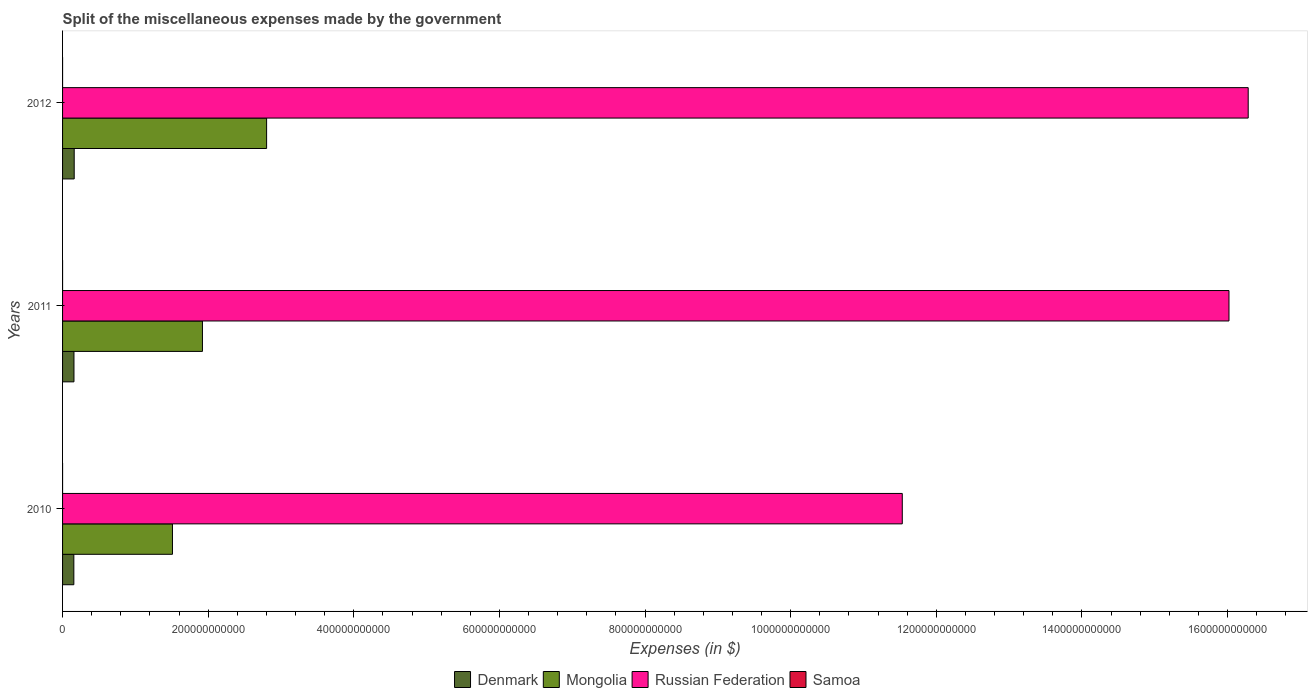How many different coloured bars are there?
Keep it short and to the point. 4. How many groups of bars are there?
Offer a very short reply. 3. Are the number of bars per tick equal to the number of legend labels?
Your response must be concise. Yes. How many bars are there on the 2nd tick from the top?
Provide a succinct answer. 4. What is the label of the 1st group of bars from the top?
Your response must be concise. 2012. In how many cases, is the number of bars for a given year not equal to the number of legend labels?
Offer a very short reply. 0. What is the miscellaneous expenses made by the government in Samoa in 2010?
Make the answer very short. 1.65e+04. Across all years, what is the maximum miscellaneous expenses made by the government in Samoa?
Provide a succinct answer. 1.76e+04. Across all years, what is the minimum miscellaneous expenses made by the government in Russian Federation?
Your answer should be very brief. 1.15e+12. In which year was the miscellaneous expenses made by the government in Denmark maximum?
Provide a succinct answer. 2012. What is the total miscellaneous expenses made by the government in Samoa in the graph?
Provide a short and direct response. 5.14e+04. What is the difference between the miscellaneous expenses made by the government in Russian Federation in 2010 and that in 2011?
Provide a succinct answer. -4.49e+11. What is the difference between the miscellaneous expenses made by the government in Mongolia in 2011 and the miscellaneous expenses made by the government in Samoa in 2012?
Ensure brevity in your answer.  1.92e+11. What is the average miscellaneous expenses made by the government in Denmark per year?
Offer a terse response. 1.57e+1. In the year 2012, what is the difference between the miscellaneous expenses made by the government in Samoa and miscellaneous expenses made by the government in Russian Federation?
Ensure brevity in your answer.  -1.63e+12. What is the ratio of the miscellaneous expenses made by the government in Russian Federation in 2010 to that in 2011?
Offer a very short reply. 0.72. Is the difference between the miscellaneous expenses made by the government in Samoa in 2011 and 2012 greater than the difference between the miscellaneous expenses made by the government in Russian Federation in 2011 and 2012?
Offer a very short reply. Yes. What is the difference between the highest and the second highest miscellaneous expenses made by the government in Samoa?
Give a very brief answer. 394.36. What is the difference between the highest and the lowest miscellaneous expenses made by the government in Mongolia?
Provide a short and direct response. 1.29e+11. Is the sum of the miscellaneous expenses made by the government in Samoa in 2011 and 2012 greater than the maximum miscellaneous expenses made by the government in Denmark across all years?
Your response must be concise. No. What does the 2nd bar from the top in 2011 represents?
Provide a short and direct response. Russian Federation. What does the 4th bar from the bottom in 2010 represents?
Provide a succinct answer. Samoa. Are all the bars in the graph horizontal?
Offer a very short reply. Yes. How many years are there in the graph?
Make the answer very short. 3. What is the difference between two consecutive major ticks on the X-axis?
Your answer should be compact. 2.00e+11. Are the values on the major ticks of X-axis written in scientific E-notation?
Your answer should be very brief. No. Does the graph contain grids?
Your response must be concise. No. Where does the legend appear in the graph?
Give a very brief answer. Bottom center. How many legend labels are there?
Ensure brevity in your answer.  4. How are the legend labels stacked?
Offer a very short reply. Horizontal. What is the title of the graph?
Give a very brief answer. Split of the miscellaneous expenses made by the government. What is the label or title of the X-axis?
Make the answer very short. Expenses (in $). What is the Expenses (in $) in Denmark in 2010?
Offer a terse response. 1.55e+1. What is the Expenses (in $) of Mongolia in 2010?
Give a very brief answer. 1.51e+11. What is the Expenses (in $) of Russian Federation in 2010?
Provide a succinct answer. 1.15e+12. What is the Expenses (in $) in Samoa in 2010?
Your answer should be compact. 1.65e+04. What is the Expenses (in $) in Denmark in 2011?
Give a very brief answer. 1.57e+1. What is the Expenses (in $) of Mongolia in 2011?
Ensure brevity in your answer.  1.92e+11. What is the Expenses (in $) of Russian Federation in 2011?
Make the answer very short. 1.60e+12. What is the Expenses (in $) in Samoa in 2011?
Ensure brevity in your answer.  1.76e+04. What is the Expenses (in $) of Denmark in 2012?
Make the answer very short. 1.60e+1. What is the Expenses (in $) in Mongolia in 2012?
Make the answer very short. 2.80e+11. What is the Expenses (in $) of Russian Federation in 2012?
Your answer should be very brief. 1.63e+12. What is the Expenses (in $) in Samoa in 2012?
Provide a succinct answer. 1.72e+04. Across all years, what is the maximum Expenses (in $) in Denmark?
Give a very brief answer. 1.60e+1. Across all years, what is the maximum Expenses (in $) in Mongolia?
Offer a very short reply. 2.80e+11. Across all years, what is the maximum Expenses (in $) in Russian Federation?
Ensure brevity in your answer.  1.63e+12. Across all years, what is the maximum Expenses (in $) of Samoa?
Your answer should be very brief. 1.76e+04. Across all years, what is the minimum Expenses (in $) of Denmark?
Provide a short and direct response. 1.55e+1. Across all years, what is the minimum Expenses (in $) in Mongolia?
Provide a succinct answer. 1.51e+11. Across all years, what is the minimum Expenses (in $) in Russian Federation?
Your response must be concise. 1.15e+12. Across all years, what is the minimum Expenses (in $) in Samoa?
Offer a terse response. 1.65e+04. What is the total Expenses (in $) of Denmark in the graph?
Ensure brevity in your answer.  4.72e+1. What is the total Expenses (in $) in Mongolia in the graph?
Ensure brevity in your answer.  6.23e+11. What is the total Expenses (in $) in Russian Federation in the graph?
Offer a terse response. 4.38e+12. What is the total Expenses (in $) of Samoa in the graph?
Your response must be concise. 5.14e+04. What is the difference between the Expenses (in $) of Denmark in 2010 and that in 2011?
Give a very brief answer. -1.65e+08. What is the difference between the Expenses (in $) of Mongolia in 2010 and that in 2011?
Keep it short and to the point. -4.12e+1. What is the difference between the Expenses (in $) in Russian Federation in 2010 and that in 2011?
Your answer should be compact. -4.49e+11. What is the difference between the Expenses (in $) of Samoa in 2010 and that in 2011?
Offer a terse response. -1087.75. What is the difference between the Expenses (in $) in Denmark in 2010 and that in 2012?
Offer a terse response. -4.86e+08. What is the difference between the Expenses (in $) in Mongolia in 2010 and that in 2012?
Your response must be concise. -1.29e+11. What is the difference between the Expenses (in $) of Russian Federation in 2010 and that in 2012?
Ensure brevity in your answer.  -4.75e+11. What is the difference between the Expenses (in $) of Samoa in 2010 and that in 2012?
Keep it short and to the point. -693.38. What is the difference between the Expenses (in $) in Denmark in 2011 and that in 2012?
Your response must be concise. -3.21e+08. What is the difference between the Expenses (in $) of Mongolia in 2011 and that in 2012?
Offer a very short reply. -8.81e+1. What is the difference between the Expenses (in $) of Russian Federation in 2011 and that in 2012?
Keep it short and to the point. -2.64e+1. What is the difference between the Expenses (in $) of Samoa in 2011 and that in 2012?
Provide a succinct answer. 394.36. What is the difference between the Expenses (in $) in Denmark in 2010 and the Expenses (in $) in Mongolia in 2011?
Offer a terse response. -1.77e+11. What is the difference between the Expenses (in $) of Denmark in 2010 and the Expenses (in $) of Russian Federation in 2011?
Offer a terse response. -1.59e+12. What is the difference between the Expenses (in $) of Denmark in 2010 and the Expenses (in $) of Samoa in 2011?
Your response must be concise. 1.55e+1. What is the difference between the Expenses (in $) in Mongolia in 2010 and the Expenses (in $) in Russian Federation in 2011?
Your answer should be compact. -1.45e+12. What is the difference between the Expenses (in $) of Mongolia in 2010 and the Expenses (in $) of Samoa in 2011?
Make the answer very short. 1.51e+11. What is the difference between the Expenses (in $) in Russian Federation in 2010 and the Expenses (in $) in Samoa in 2011?
Your answer should be very brief. 1.15e+12. What is the difference between the Expenses (in $) in Denmark in 2010 and the Expenses (in $) in Mongolia in 2012?
Your answer should be compact. -2.65e+11. What is the difference between the Expenses (in $) of Denmark in 2010 and the Expenses (in $) of Russian Federation in 2012?
Provide a short and direct response. -1.61e+12. What is the difference between the Expenses (in $) in Denmark in 2010 and the Expenses (in $) in Samoa in 2012?
Your response must be concise. 1.55e+1. What is the difference between the Expenses (in $) of Mongolia in 2010 and the Expenses (in $) of Russian Federation in 2012?
Your response must be concise. -1.48e+12. What is the difference between the Expenses (in $) of Mongolia in 2010 and the Expenses (in $) of Samoa in 2012?
Your answer should be very brief. 1.51e+11. What is the difference between the Expenses (in $) in Russian Federation in 2010 and the Expenses (in $) in Samoa in 2012?
Make the answer very short. 1.15e+12. What is the difference between the Expenses (in $) in Denmark in 2011 and the Expenses (in $) in Mongolia in 2012?
Offer a terse response. -2.65e+11. What is the difference between the Expenses (in $) of Denmark in 2011 and the Expenses (in $) of Russian Federation in 2012?
Offer a terse response. -1.61e+12. What is the difference between the Expenses (in $) of Denmark in 2011 and the Expenses (in $) of Samoa in 2012?
Your response must be concise. 1.57e+1. What is the difference between the Expenses (in $) in Mongolia in 2011 and the Expenses (in $) in Russian Federation in 2012?
Offer a very short reply. -1.44e+12. What is the difference between the Expenses (in $) in Mongolia in 2011 and the Expenses (in $) in Samoa in 2012?
Offer a terse response. 1.92e+11. What is the difference between the Expenses (in $) of Russian Federation in 2011 and the Expenses (in $) of Samoa in 2012?
Provide a short and direct response. 1.60e+12. What is the average Expenses (in $) in Denmark per year?
Provide a short and direct response. 1.57e+1. What is the average Expenses (in $) in Mongolia per year?
Provide a succinct answer. 2.08e+11. What is the average Expenses (in $) in Russian Federation per year?
Offer a very short reply. 1.46e+12. What is the average Expenses (in $) in Samoa per year?
Ensure brevity in your answer.  1.71e+04. In the year 2010, what is the difference between the Expenses (in $) in Denmark and Expenses (in $) in Mongolia?
Offer a very short reply. -1.35e+11. In the year 2010, what is the difference between the Expenses (in $) of Denmark and Expenses (in $) of Russian Federation?
Your answer should be compact. -1.14e+12. In the year 2010, what is the difference between the Expenses (in $) of Denmark and Expenses (in $) of Samoa?
Give a very brief answer. 1.55e+1. In the year 2010, what is the difference between the Expenses (in $) of Mongolia and Expenses (in $) of Russian Federation?
Offer a terse response. -1.00e+12. In the year 2010, what is the difference between the Expenses (in $) of Mongolia and Expenses (in $) of Samoa?
Make the answer very short. 1.51e+11. In the year 2010, what is the difference between the Expenses (in $) of Russian Federation and Expenses (in $) of Samoa?
Offer a terse response. 1.15e+12. In the year 2011, what is the difference between the Expenses (in $) of Denmark and Expenses (in $) of Mongolia?
Your answer should be compact. -1.76e+11. In the year 2011, what is the difference between the Expenses (in $) of Denmark and Expenses (in $) of Russian Federation?
Provide a succinct answer. -1.59e+12. In the year 2011, what is the difference between the Expenses (in $) of Denmark and Expenses (in $) of Samoa?
Ensure brevity in your answer.  1.57e+1. In the year 2011, what is the difference between the Expenses (in $) in Mongolia and Expenses (in $) in Russian Federation?
Make the answer very short. -1.41e+12. In the year 2011, what is the difference between the Expenses (in $) in Mongolia and Expenses (in $) in Samoa?
Offer a very short reply. 1.92e+11. In the year 2011, what is the difference between the Expenses (in $) in Russian Federation and Expenses (in $) in Samoa?
Your response must be concise. 1.60e+12. In the year 2012, what is the difference between the Expenses (in $) in Denmark and Expenses (in $) in Mongolia?
Your answer should be very brief. -2.64e+11. In the year 2012, what is the difference between the Expenses (in $) of Denmark and Expenses (in $) of Russian Federation?
Provide a succinct answer. -1.61e+12. In the year 2012, what is the difference between the Expenses (in $) in Denmark and Expenses (in $) in Samoa?
Provide a succinct answer. 1.60e+1. In the year 2012, what is the difference between the Expenses (in $) of Mongolia and Expenses (in $) of Russian Federation?
Provide a short and direct response. -1.35e+12. In the year 2012, what is the difference between the Expenses (in $) in Mongolia and Expenses (in $) in Samoa?
Offer a terse response. 2.80e+11. In the year 2012, what is the difference between the Expenses (in $) in Russian Federation and Expenses (in $) in Samoa?
Your answer should be compact. 1.63e+12. What is the ratio of the Expenses (in $) in Denmark in 2010 to that in 2011?
Provide a succinct answer. 0.99. What is the ratio of the Expenses (in $) in Mongolia in 2010 to that in 2011?
Provide a succinct answer. 0.79. What is the ratio of the Expenses (in $) of Russian Federation in 2010 to that in 2011?
Make the answer very short. 0.72. What is the ratio of the Expenses (in $) of Samoa in 2010 to that in 2011?
Your answer should be very brief. 0.94. What is the ratio of the Expenses (in $) in Denmark in 2010 to that in 2012?
Provide a short and direct response. 0.97. What is the ratio of the Expenses (in $) of Mongolia in 2010 to that in 2012?
Ensure brevity in your answer.  0.54. What is the ratio of the Expenses (in $) of Russian Federation in 2010 to that in 2012?
Your answer should be very brief. 0.71. What is the ratio of the Expenses (in $) in Samoa in 2010 to that in 2012?
Your response must be concise. 0.96. What is the ratio of the Expenses (in $) in Denmark in 2011 to that in 2012?
Your response must be concise. 0.98. What is the ratio of the Expenses (in $) in Mongolia in 2011 to that in 2012?
Make the answer very short. 0.69. What is the ratio of the Expenses (in $) of Russian Federation in 2011 to that in 2012?
Your response must be concise. 0.98. What is the ratio of the Expenses (in $) of Samoa in 2011 to that in 2012?
Keep it short and to the point. 1.02. What is the difference between the highest and the second highest Expenses (in $) in Denmark?
Your response must be concise. 3.21e+08. What is the difference between the highest and the second highest Expenses (in $) in Mongolia?
Make the answer very short. 8.81e+1. What is the difference between the highest and the second highest Expenses (in $) in Russian Federation?
Offer a very short reply. 2.64e+1. What is the difference between the highest and the second highest Expenses (in $) in Samoa?
Make the answer very short. 394.36. What is the difference between the highest and the lowest Expenses (in $) in Denmark?
Give a very brief answer. 4.86e+08. What is the difference between the highest and the lowest Expenses (in $) in Mongolia?
Your response must be concise. 1.29e+11. What is the difference between the highest and the lowest Expenses (in $) in Russian Federation?
Give a very brief answer. 4.75e+11. What is the difference between the highest and the lowest Expenses (in $) in Samoa?
Offer a terse response. 1087.75. 